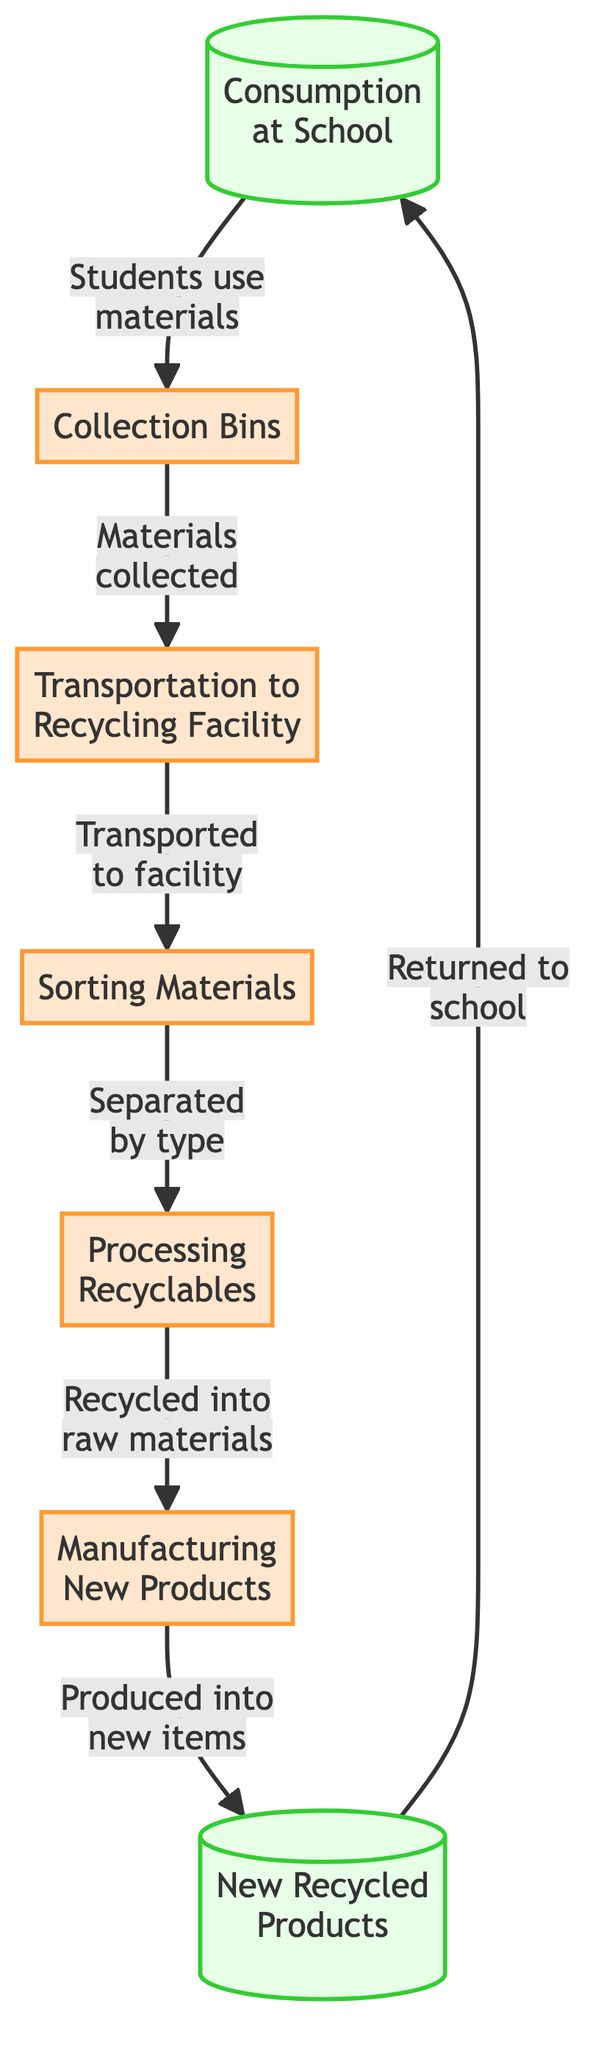What is the first step in the flowchart? The first step in the flowchart is "Consumption at School," which indicates where the process begins as students use recyclable materials.
Answer: Consumption at School How many steps are there in total? By counting all the distinct steps from consumption to new products, there are six steps in total within the flowchart.
Answer: 6 What follows after the "Sorting Materials" step? The step that follows "Sorting Materials" is "Processing Recyclables," where the sorted materials are processed into raw materials.
Answer: Processing Recyclables Which step involves transportation? The step that involves transportation is "Transportation to Recycling Facility," where collected materials are transported to the recycling facility after being placed in collection bins.
Answer: Transportation to Recycling Facility What materials are collected in the "Collection Bins"? The materials collected in "Collection Bins" are recyclable materials, which students use and then dispose of in these designated bins.
Answer: Recyclable materials Which step produces new items? The step that produces new items is "Manufacturing New Products," where the processed materials are turned into new products.
Answer: Manufacturing New Products Describe the relationship between "Processing Recyclables" and "Manufacturing New Products." "Processing Recyclables" converts sorted materials into raw materials, which are then used in the subsequent step "Manufacturing New Products" to create new items.
Answer: Converts raw materials to new items What type of node is "New Recycled Products"? "New Recycled Products" is classified as a product node in the flowchart, indicating it is the result of the recycling process.
Answer: Product How do new recycled products return to the beginning of the flowchart? New recycled products return to the beginning of the flowchart by being sent back to the "Consumption at School" step, where they are used again by students.
Answer: Returned to school 